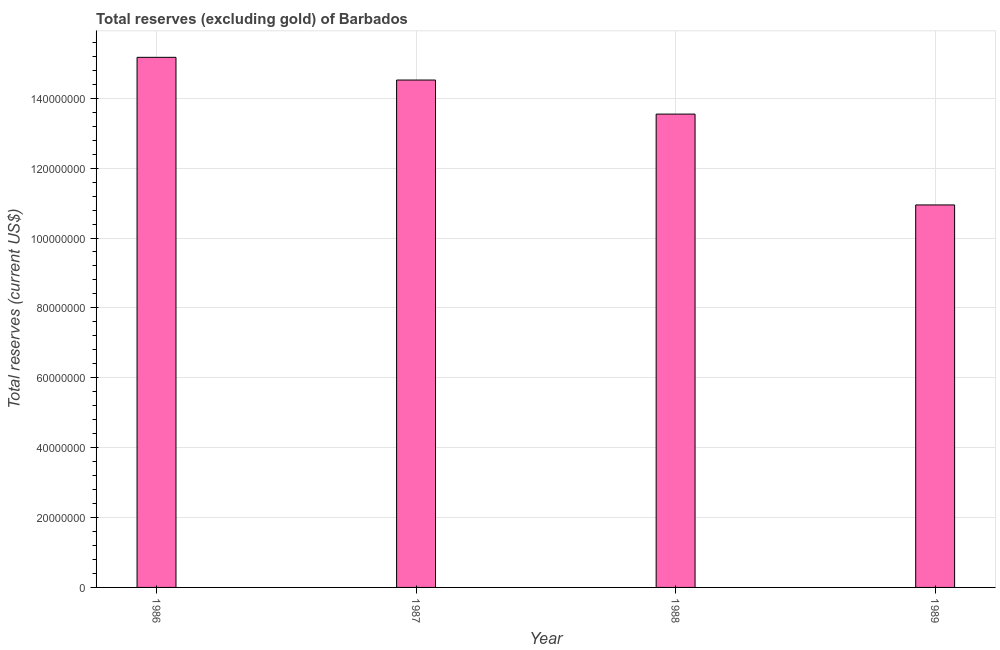Does the graph contain any zero values?
Your response must be concise. No. What is the title of the graph?
Offer a terse response. Total reserves (excluding gold) of Barbados. What is the label or title of the X-axis?
Offer a very short reply. Year. What is the label or title of the Y-axis?
Your answer should be very brief. Total reserves (current US$). What is the total reserves (excluding gold) in 1989?
Keep it short and to the point. 1.09e+08. Across all years, what is the maximum total reserves (excluding gold)?
Make the answer very short. 1.52e+08. Across all years, what is the minimum total reserves (excluding gold)?
Offer a very short reply. 1.09e+08. In which year was the total reserves (excluding gold) minimum?
Offer a terse response. 1989. What is the sum of the total reserves (excluding gold)?
Offer a terse response. 5.42e+08. What is the difference between the total reserves (excluding gold) in 1986 and 1989?
Provide a short and direct response. 4.22e+07. What is the average total reserves (excluding gold) per year?
Your answer should be very brief. 1.35e+08. What is the median total reserves (excluding gold)?
Provide a short and direct response. 1.40e+08. What is the ratio of the total reserves (excluding gold) in 1986 to that in 1987?
Offer a very short reply. 1.04. Is the total reserves (excluding gold) in 1988 less than that in 1989?
Offer a terse response. No. Is the difference between the total reserves (excluding gold) in 1987 and 1989 greater than the difference between any two years?
Give a very brief answer. No. What is the difference between the highest and the second highest total reserves (excluding gold)?
Offer a very short reply. 6.50e+06. Is the sum of the total reserves (excluding gold) in 1986 and 1989 greater than the maximum total reserves (excluding gold) across all years?
Make the answer very short. Yes. What is the difference between the highest and the lowest total reserves (excluding gold)?
Offer a terse response. 4.22e+07. In how many years, is the total reserves (excluding gold) greater than the average total reserves (excluding gold) taken over all years?
Offer a very short reply. 2. How many bars are there?
Offer a very short reply. 4. What is the Total reserves (current US$) in 1986?
Give a very brief answer. 1.52e+08. What is the Total reserves (current US$) in 1987?
Your response must be concise. 1.45e+08. What is the Total reserves (current US$) in 1988?
Keep it short and to the point. 1.35e+08. What is the Total reserves (current US$) in 1989?
Your answer should be very brief. 1.09e+08. What is the difference between the Total reserves (current US$) in 1986 and 1987?
Ensure brevity in your answer.  6.50e+06. What is the difference between the Total reserves (current US$) in 1986 and 1988?
Make the answer very short. 1.62e+07. What is the difference between the Total reserves (current US$) in 1986 and 1989?
Your response must be concise. 4.22e+07. What is the difference between the Total reserves (current US$) in 1987 and 1988?
Offer a very short reply. 9.75e+06. What is the difference between the Total reserves (current US$) in 1987 and 1989?
Your response must be concise. 3.57e+07. What is the difference between the Total reserves (current US$) in 1988 and 1989?
Make the answer very short. 2.60e+07. What is the ratio of the Total reserves (current US$) in 1986 to that in 1987?
Your response must be concise. 1.04. What is the ratio of the Total reserves (current US$) in 1986 to that in 1988?
Your response must be concise. 1.12. What is the ratio of the Total reserves (current US$) in 1986 to that in 1989?
Make the answer very short. 1.39. What is the ratio of the Total reserves (current US$) in 1987 to that in 1988?
Give a very brief answer. 1.07. What is the ratio of the Total reserves (current US$) in 1987 to that in 1989?
Provide a short and direct response. 1.33. What is the ratio of the Total reserves (current US$) in 1988 to that in 1989?
Ensure brevity in your answer.  1.24. 